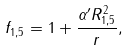<formula> <loc_0><loc_0><loc_500><loc_500>f _ { 1 , 5 } = 1 + \frac { \alpha ^ { \prime } R _ { 1 , 5 } ^ { 2 } } { r } ,</formula> 